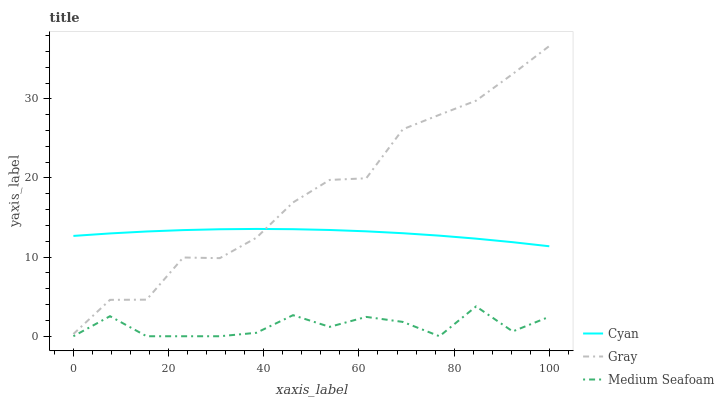Does Medium Seafoam have the minimum area under the curve?
Answer yes or no. Yes. Does Gray have the maximum area under the curve?
Answer yes or no. Yes. Does Gray have the minimum area under the curve?
Answer yes or no. No. Does Medium Seafoam have the maximum area under the curve?
Answer yes or no. No. Is Cyan the smoothest?
Answer yes or no. Yes. Is Medium Seafoam the roughest?
Answer yes or no. Yes. Is Gray the smoothest?
Answer yes or no. No. Is Gray the roughest?
Answer yes or no. No. Does Gray have the lowest value?
Answer yes or no. No. Does Medium Seafoam have the highest value?
Answer yes or no. No. Is Medium Seafoam less than Cyan?
Answer yes or no. Yes. Is Cyan greater than Medium Seafoam?
Answer yes or no. Yes. Does Medium Seafoam intersect Cyan?
Answer yes or no. No. 